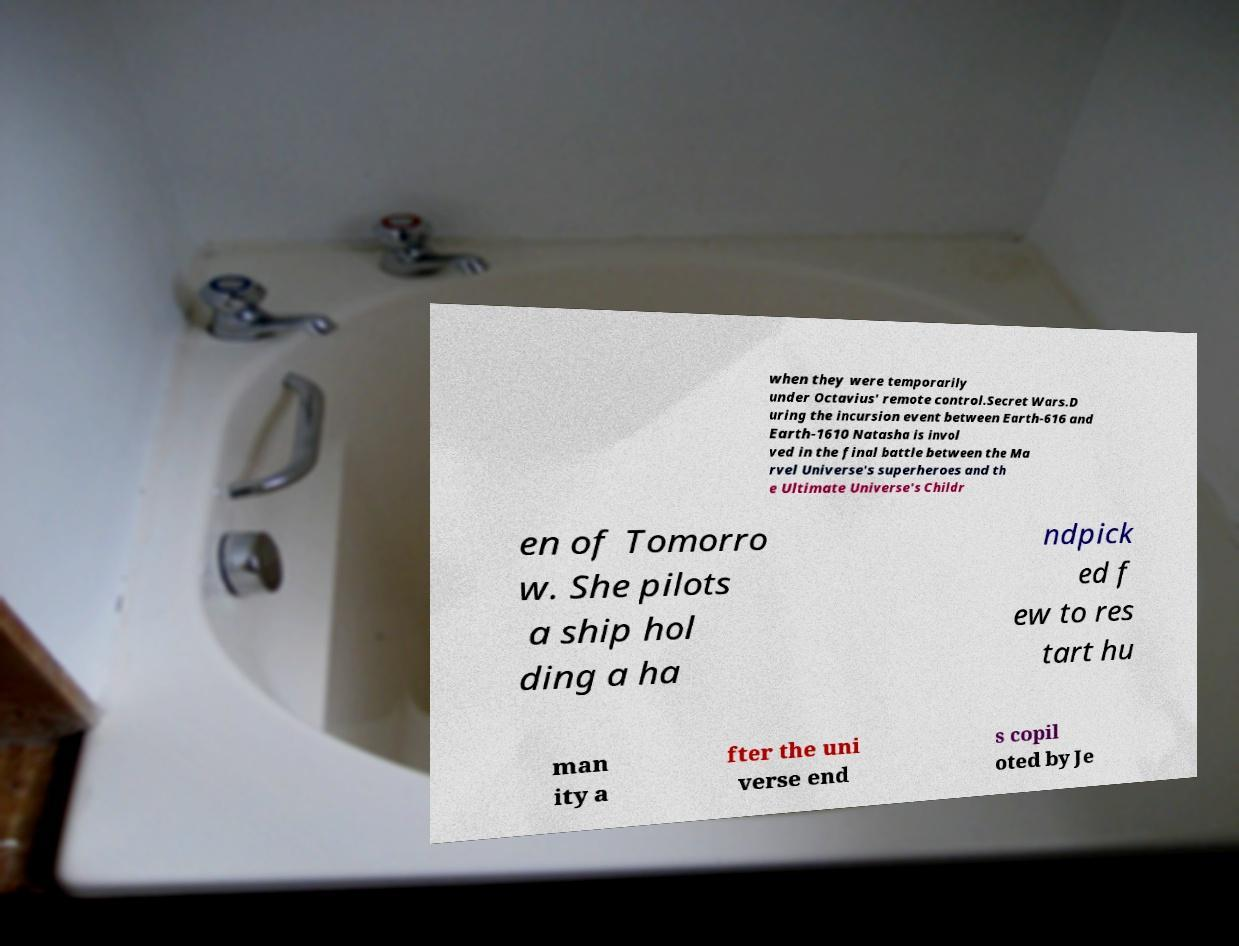I need the written content from this picture converted into text. Can you do that? when they were temporarily under Octavius' remote control.Secret Wars.D uring the incursion event between Earth-616 and Earth-1610 Natasha is invol ved in the final battle between the Ma rvel Universe's superheroes and th e Ultimate Universe's Childr en of Tomorro w. She pilots a ship hol ding a ha ndpick ed f ew to res tart hu man ity a fter the uni verse end s copil oted by Je 